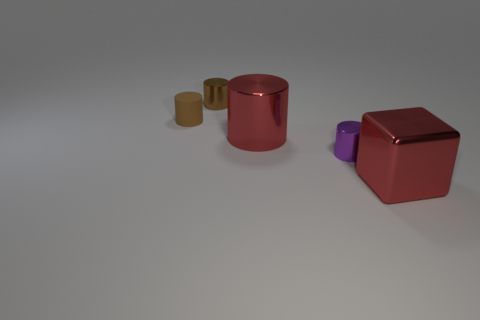Can you describe the colors and materials of the objects in the image? Sure, there are four objects in the image with different colors and materials. From left to right, we have a small gold matte cylinder, a larger copper matte cylinder, a purple matte cylinder, and a large red glossy cube. 